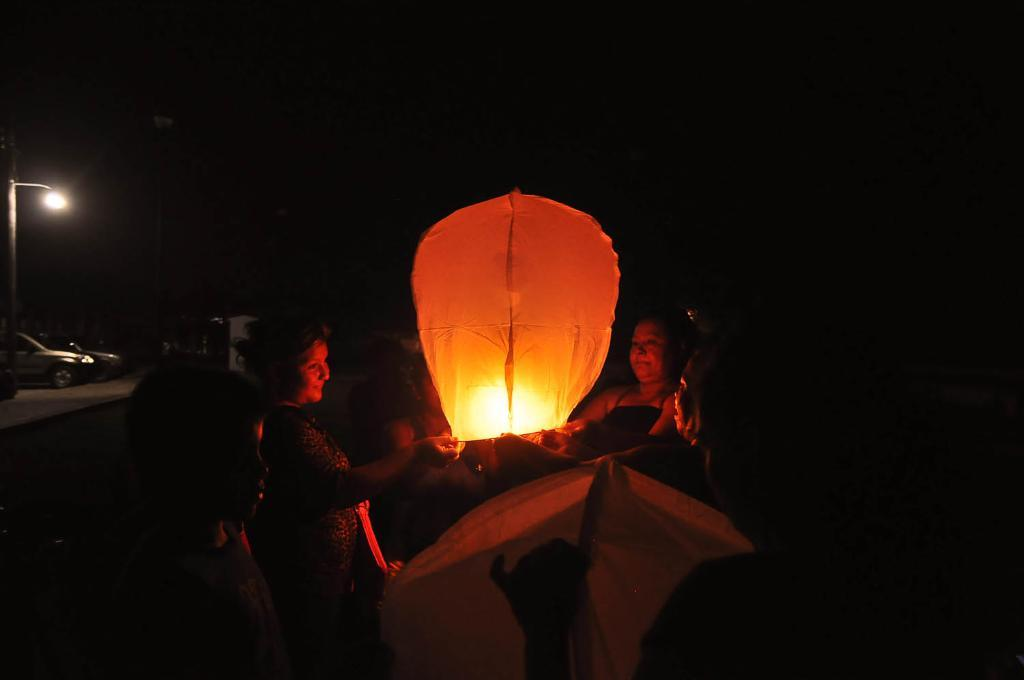Who or what can be seen in the image? There are people in the image. What are the people doing or interacting with in the image? Sky lanterns are present in the image, suggesting that the people might be involved in a sky lantern event or activity. What else is visible on the left side of the image? Vehicles are visible on the left side of the image. What structure can be seen in the image? There is an electric pole in the image. How would you describe the lighting or time of day in the image? The background of the image appears to be dark, which might suggest that the image was taken at night or in low light conditions. What type of wound can be seen on the plate in the image? There is no plate or wound present in the image. Are the people in the image engaged in a fight? There is no indication of a fight or any conflict in the image. 